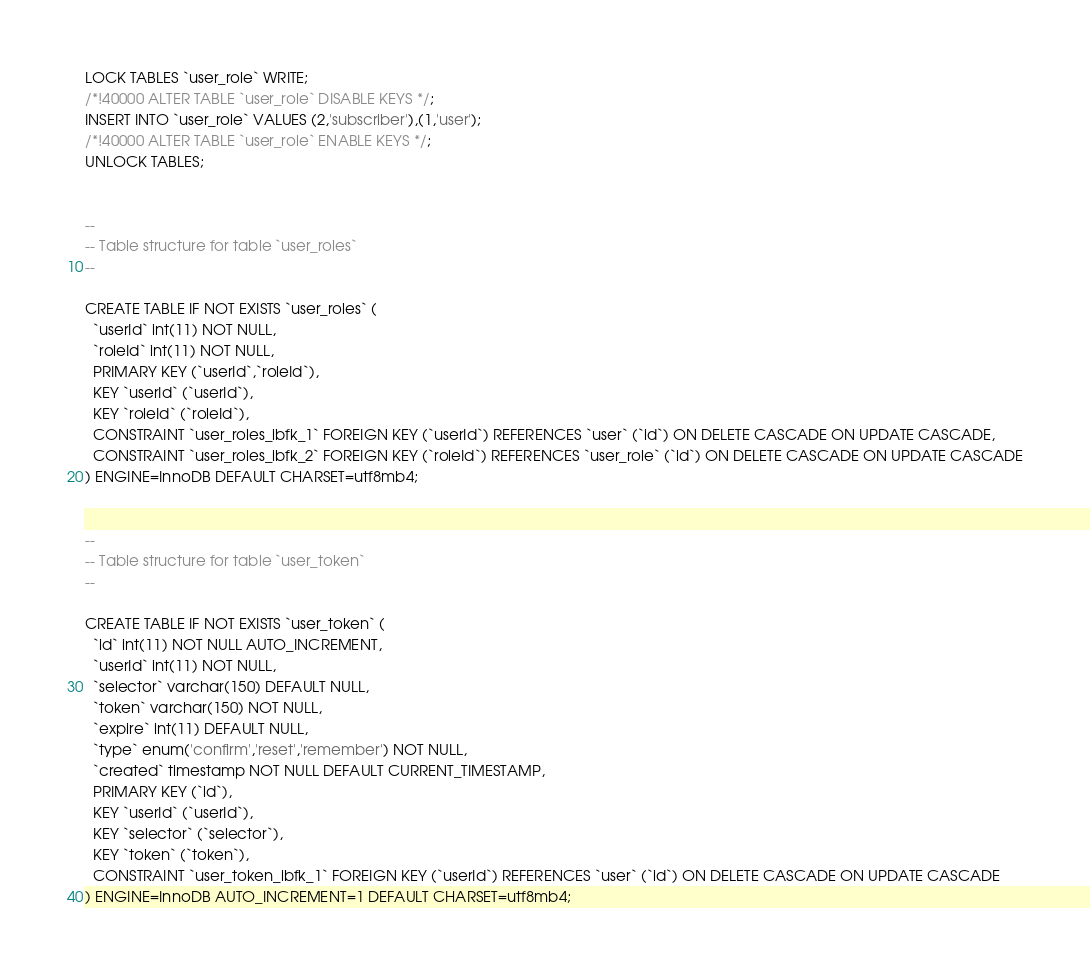Convert code to text. <code><loc_0><loc_0><loc_500><loc_500><_SQL_>LOCK TABLES `user_role` WRITE;
/*!40000 ALTER TABLE `user_role` DISABLE KEYS */;
INSERT INTO `user_role` VALUES (2,'subscriber'),(1,'user');
/*!40000 ALTER TABLE `user_role` ENABLE KEYS */;
UNLOCK TABLES;


--
-- Table structure for table `user_roles`
--

CREATE TABLE IF NOT EXISTS `user_roles` (
  `userId` int(11) NOT NULL,
  `roleId` int(11) NOT NULL,
  PRIMARY KEY (`userId`,`roleId`),
  KEY `userId` (`userId`),
  KEY `roleId` (`roleId`),
  CONSTRAINT `user_roles_ibfk_1` FOREIGN KEY (`userId`) REFERENCES `user` (`id`) ON DELETE CASCADE ON UPDATE CASCADE,
  CONSTRAINT `user_roles_ibfk_2` FOREIGN KEY (`roleId`) REFERENCES `user_role` (`id`) ON DELETE CASCADE ON UPDATE CASCADE
) ENGINE=InnoDB DEFAULT CHARSET=utf8mb4;


--
-- Table structure for table `user_token`
--

CREATE TABLE IF NOT EXISTS `user_token` (
  `id` int(11) NOT NULL AUTO_INCREMENT,
  `userId` int(11) NOT NULL,
  `selector` varchar(150) DEFAULT NULL,
  `token` varchar(150) NOT NULL,
  `expire` int(11) DEFAULT NULL,
  `type` enum('confirm','reset','remember') NOT NULL,
  `created` timestamp NOT NULL DEFAULT CURRENT_TIMESTAMP,
  PRIMARY KEY (`id`),
  KEY `userId` (`userId`),
  KEY `selector` (`selector`),
  KEY `token` (`token`),
  CONSTRAINT `user_token_ibfk_1` FOREIGN KEY (`userId`) REFERENCES `user` (`id`) ON DELETE CASCADE ON UPDATE CASCADE
) ENGINE=InnoDB AUTO_INCREMENT=1 DEFAULT CHARSET=utf8mb4;
</code> 